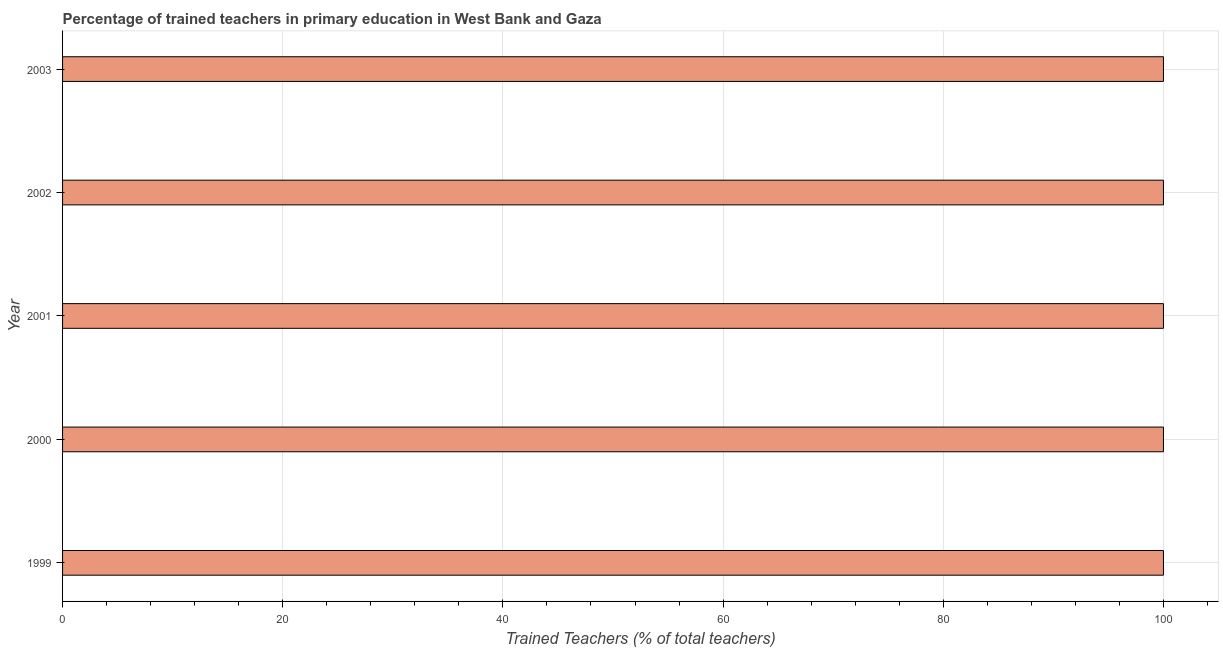What is the title of the graph?
Ensure brevity in your answer.  Percentage of trained teachers in primary education in West Bank and Gaza. What is the label or title of the X-axis?
Make the answer very short. Trained Teachers (% of total teachers). What is the label or title of the Y-axis?
Offer a very short reply. Year. In which year was the percentage of trained teachers minimum?
Offer a very short reply. 1999. What is the sum of the percentage of trained teachers?
Offer a very short reply. 500. What is the median percentage of trained teachers?
Provide a short and direct response. 100. In how many years, is the percentage of trained teachers greater than 12 %?
Your answer should be compact. 5. What is the ratio of the percentage of trained teachers in 2000 to that in 2002?
Offer a terse response. 1. Is the percentage of trained teachers in 2001 less than that in 2002?
Offer a very short reply. No. What is the difference between the highest and the lowest percentage of trained teachers?
Provide a succinct answer. 0. In how many years, is the percentage of trained teachers greater than the average percentage of trained teachers taken over all years?
Your response must be concise. 0. Are all the bars in the graph horizontal?
Offer a terse response. Yes. What is the difference between two consecutive major ticks on the X-axis?
Ensure brevity in your answer.  20. Are the values on the major ticks of X-axis written in scientific E-notation?
Offer a very short reply. No. What is the Trained Teachers (% of total teachers) of 1999?
Provide a short and direct response. 100. What is the Trained Teachers (% of total teachers) in 2002?
Give a very brief answer. 100. What is the Trained Teachers (% of total teachers) of 2003?
Your response must be concise. 100. What is the difference between the Trained Teachers (% of total teachers) in 1999 and 2001?
Your answer should be very brief. 0. What is the difference between the Trained Teachers (% of total teachers) in 1999 and 2003?
Offer a very short reply. 0. What is the difference between the Trained Teachers (% of total teachers) in 2000 and 2001?
Ensure brevity in your answer.  0. What is the ratio of the Trained Teachers (% of total teachers) in 1999 to that in 2001?
Provide a short and direct response. 1. What is the ratio of the Trained Teachers (% of total teachers) in 1999 to that in 2003?
Give a very brief answer. 1. What is the ratio of the Trained Teachers (% of total teachers) in 2000 to that in 2002?
Give a very brief answer. 1. What is the ratio of the Trained Teachers (% of total teachers) in 2001 to that in 2002?
Your answer should be compact. 1. 